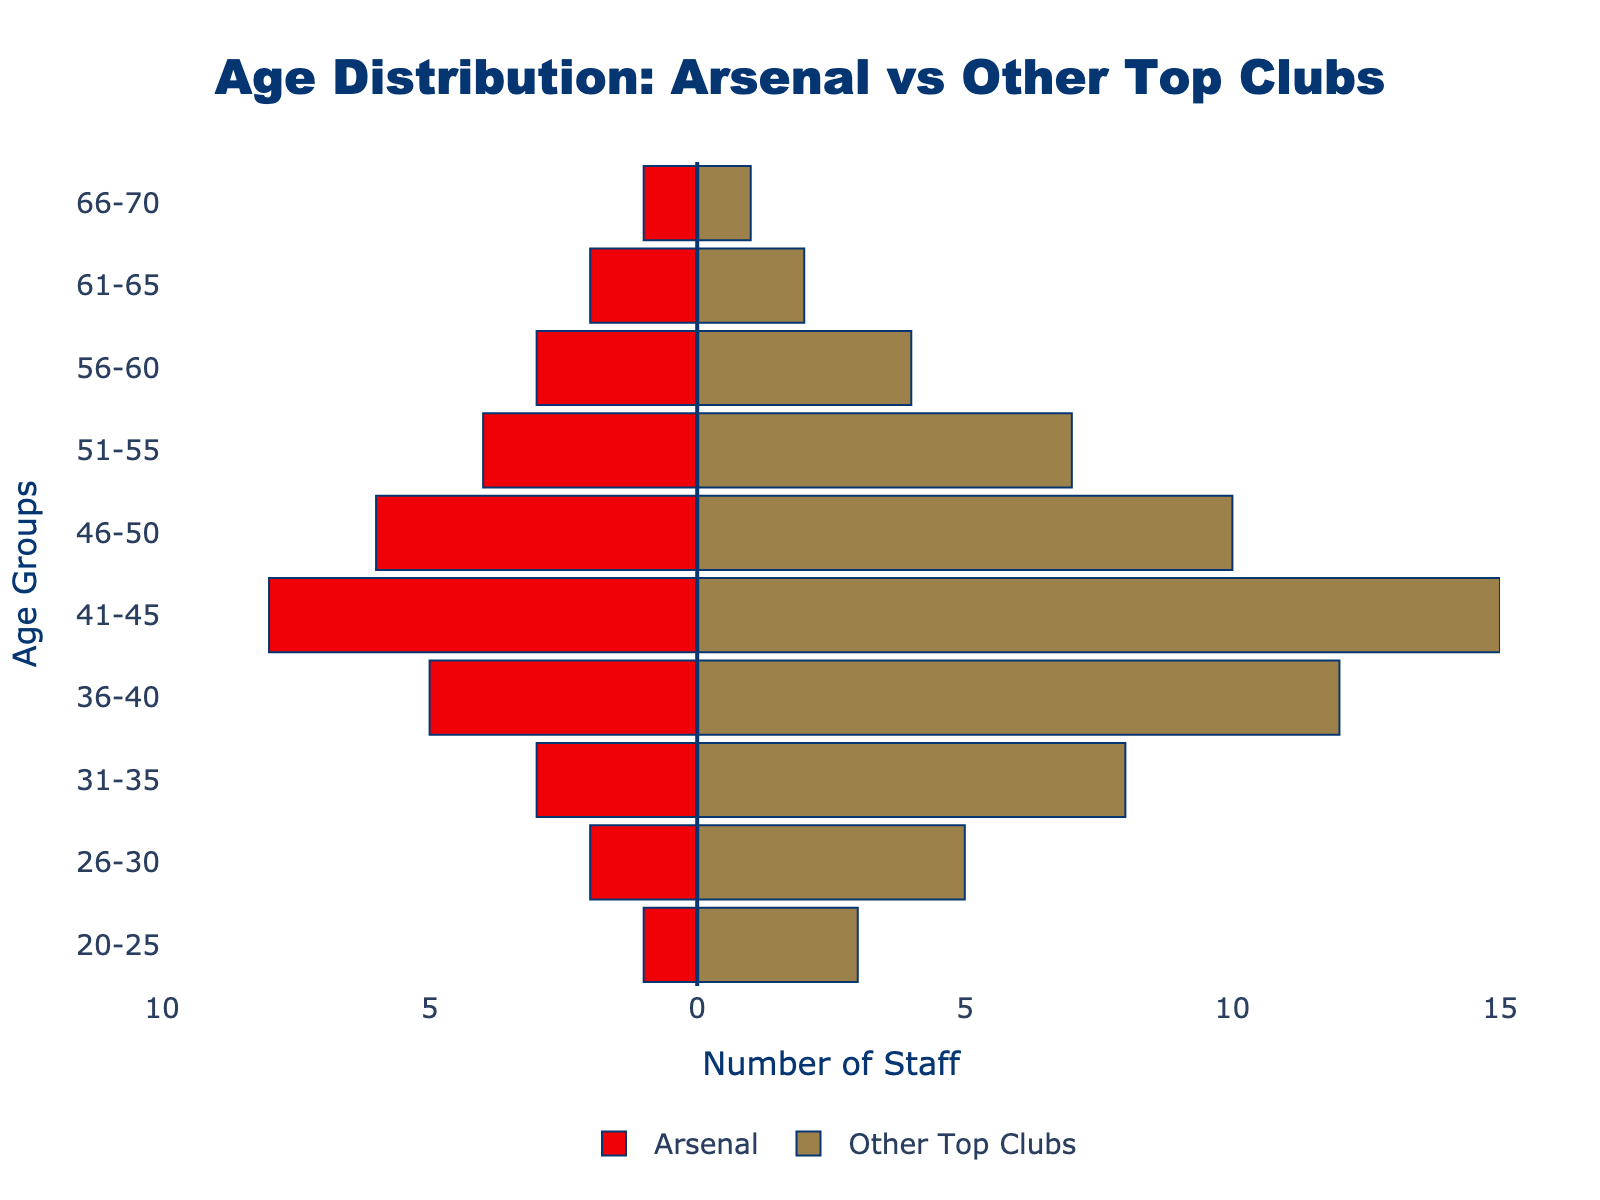What is the age group with the highest number of staff for Arsenal? From the figure, the age group with the highest number of staff for Arsenal is shown by the longest bar on the left. This is the 41-45 age group with 8 staff.
Answer: 41-45 How many more staff do other top clubs have in the 36-40 age group compared to Arsenal? The figure shows that other top clubs have 12 staff in the 36-40 age group, while Arsenal has 5. Subtracting Arsenal's number from other top clubs' number gives 12 - 5 = 7.
Answer: 7 In which age group are the numbers of staff for Arsenal and other top clubs equal? The figure shows that the only age group where the length of the bars for Arsenal and other top clubs are equal is the 66-70 age group, both having 1 staff.
Answer: 66-70 What is the total number of coaching staff in Arsenal aged 46 or older? Sum the values of the bars on the left (Arsenal) for the age groups 46-50, 51-55, 56-60, 61-65, and 66-70: (6 + 4 + 3 + 2 + 1) = 16.
Answer: 16 How does the age distribution of Arsenal's staff compare to other top clubs in the 36-45 age range? From the figure, summing Arsenal's staff in the 36-40 and 41-45 groups gives 5 + 8 = 13. For other top clubs, it's 12 + 15 = 27. Other top clubs have more staff in this age range compared to Arsenal.
Answer: Other top clubs have more staff Which age group has the smallest difference between Arsenal and other top clubs? The figure indicates that the smallest difference is in the 61-65 and 66-70 age groups, where both Arsenal and other top clubs have 2 and 1 staff, respectively. The difference is 0.
Answer: 61-65 and 66-70 How many staff members are there in total for Arsenal and other top clubs in the 31-35 age group? Looking at the bars for the 31-35 age group, Arsenal has 3 staff and other top clubs have 8. Adding them together gives 3 + 8 = 11.
Answer: 11 What is the average number of staff aged 20-35 for Arsenal? For Arsenal, sum the number of staff in the 20-25, 26-30, and 31-35 age groups: (1 + 2 + 3) = 6. Since there are 3 age groups, the average is 6 / 3 = 2.
Answer: 2 Between the ages of 36 to 55, which club has a higher total number of staff? Sum Arsenal's staff in the 36-40, 41-45, 46-50, and 51-55 groups: (5 + 8 + 6 + 4) = 23. Sum other top clubs' staff in the same age groups: (12 + 15 + 10 + 7) = 44. Other top clubs have a higher total.
Answer: Other top clubs Are there age groups where Arsenal has more staff than other top clubs? If so, which ones? Look for age groups where the bar for Arsenal is longer than for other top clubs. There are none in the given data; other top clubs always have more or equal staff.
Answer: None 